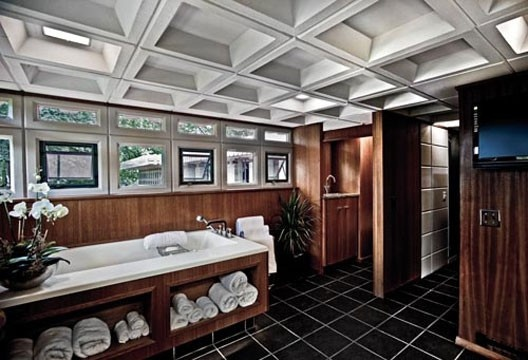Describe the objects in this image and their specific colors. I can see potted plant in black, darkgray, gray, and lightgray tones, tv in black, navy, and blue tones, potted plant in black, maroon, and gray tones, tv in black, darkgray, gray, and purple tones, and sink in black, maroon, gray, and tan tones in this image. 